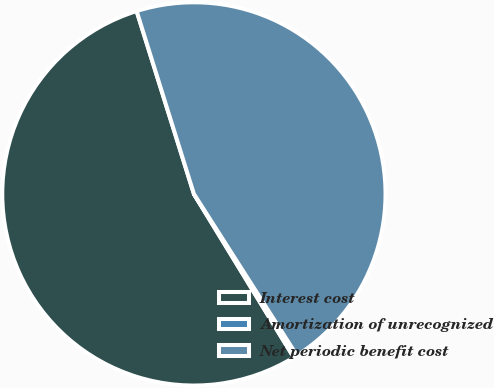<chart> <loc_0><loc_0><loc_500><loc_500><pie_chart><fcel>Interest cost<fcel>Amortization of unrecognized<fcel>Net periodic benefit cost<nl><fcel>53.89%<fcel>0.31%<fcel>45.79%<nl></chart> 